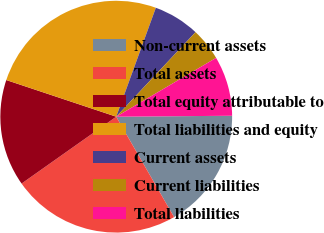Convert chart to OTSL. <chart><loc_0><loc_0><loc_500><loc_500><pie_chart><fcel>Non-current assets<fcel>Total assets<fcel>Total equity attributable to<fcel>Total liabilities and equity<fcel>Current assets<fcel>Current liabilities<fcel>Total liabilities<nl><fcel>16.81%<fcel>23.53%<fcel>14.91%<fcel>25.43%<fcel>6.44%<fcel>4.54%<fcel>8.34%<nl></chart> 